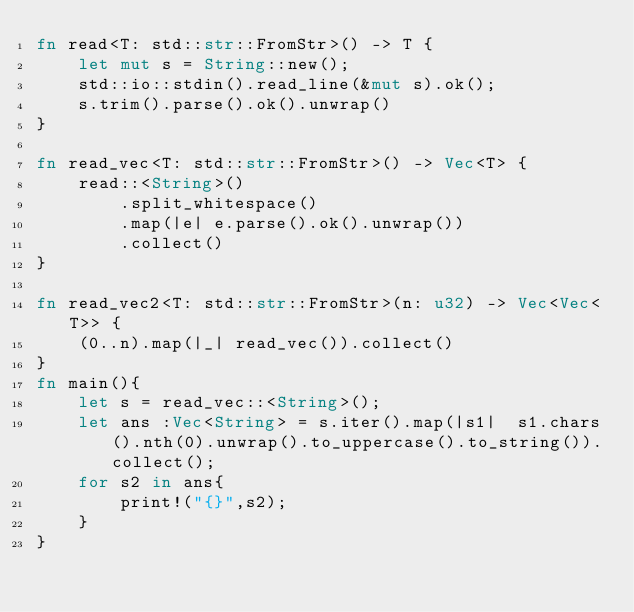Convert code to text. <code><loc_0><loc_0><loc_500><loc_500><_Rust_>fn read<T: std::str::FromStr>() -> T {
    let mut s = String::new();
    std::io::stdin().read_line(&mut s).ok();
    s.trim().parse().ok().unwrap()
}

fn read_vec<T: std::str::FromStr>() -> Vec<T> {
    read::<String>()
        .split_whitespace()
        .map(|e| e.parse().ok().unwrap())
        .collect()
}

fn read_vec2<T: std::str::FromStr>(n: u32) -> Vec<Vec<T>> {
    (0..n).map(|_| read_vec()).collect()
}
fn main(){
    let s = read_vec::<String>();
    let ans :Vec<String> = s.iter().map(|s1|  s1.chars().nth(0).unwrap().to_uppercase().to_string()).collect();
    for s2 in ans{
        print!("{}",s2);
    } 
}</code> 